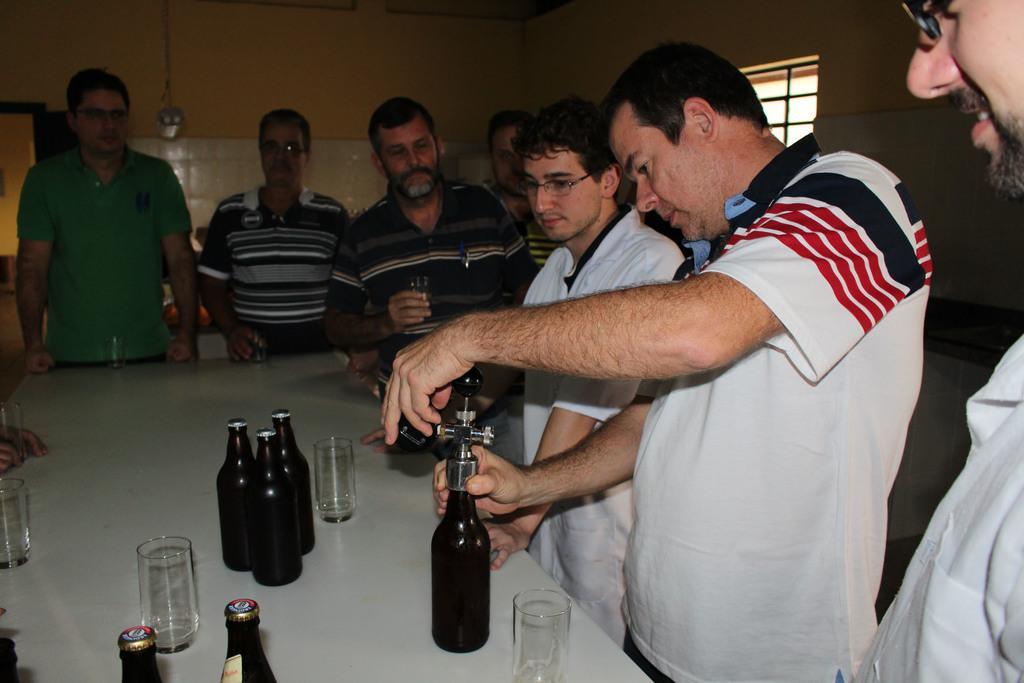Could you give a brief overview of what you see in this image? Here we can see a group of people standing in front of a table having glasses and bottles present on it and the person in the front is opening the cap of the bottle 